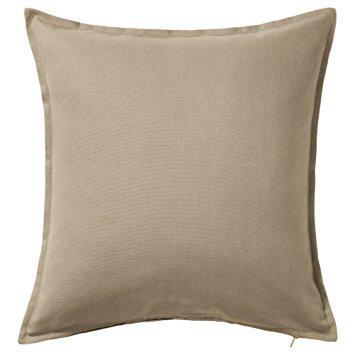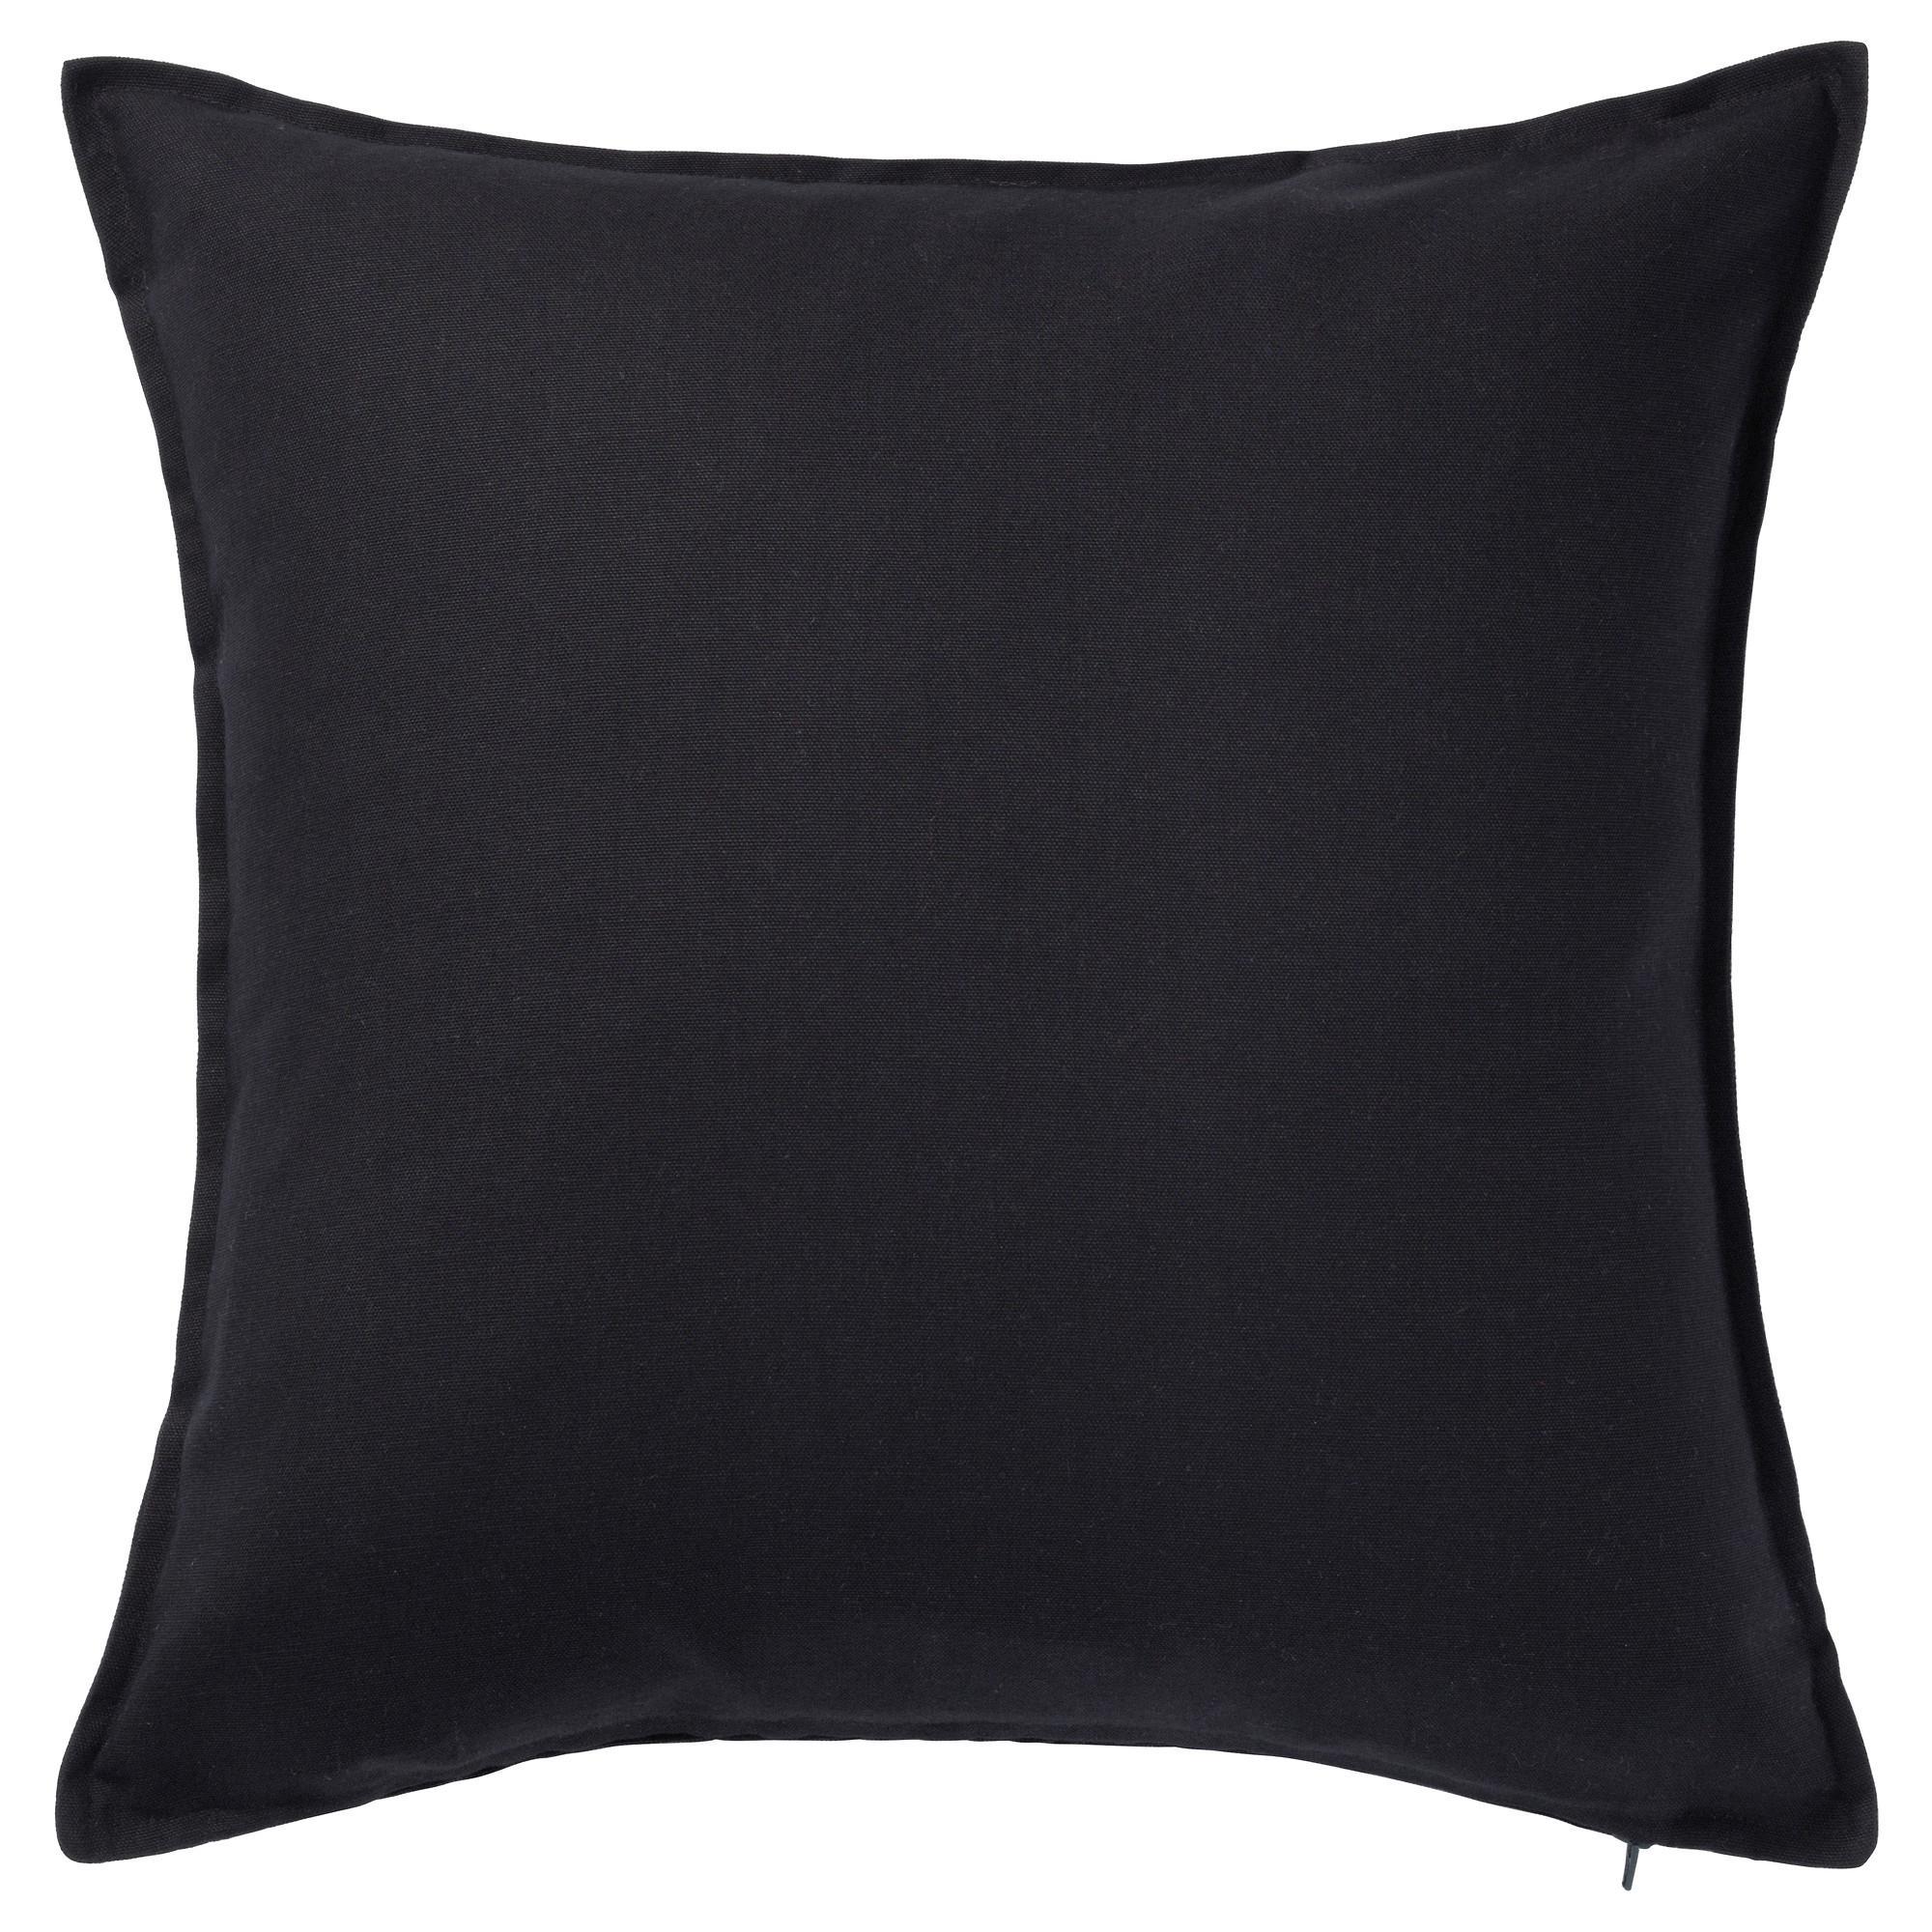The first image is the image on the left, the second image is the image on the right. Given the left and right images, does the statement "An image shows the corner of a white sofa containing a solid-colored pillow overlapping a striped pillow, and a smaller printed pillow to the right." hold true? Answer yes or no. No. The first image is the image on the left, the second image is the image on the right. Given the left and right images, does the statement "One image shows pillows on a sofa and the other shows a single pillow." hold true? Answer yes or no. No. 